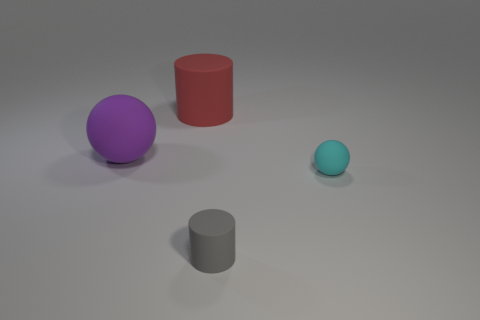Are there an equal number of tiny things that are to the left of the small cyan object and big purple things?
Make the answer very short. Yes. There is a cylinder that is to the right of the cylinder behind the gray object; is there a red rubber thing on the right side of it?
Provide a short and direct response. No. Are there fewer large red cylinders in front of the tiny gray matte object than large matte balls?
Your answer should be very brief. Yes. What number of objects are matte spheres to the right of the gray matte cylinder or purple objects on the left side of the large red cylinder?
Keep it short and to the point. 2. What is the size of the matte object that is both on the left side of the tiny cylinder and on the right side of the purple ball?
Offer a terse response. Large. Do the matte object that is to the right of the gray rubber cylinder and the big purple thing have the same shape?
Provide a short and direct response. Yes. How big is the rubber cylinder behind the rubber cylinder in front of the sphere that is left of the small matte sphere?
Offer a terse response. Large. What number of things are big gray cylinders or large rubber cylinders?
Provide a succinct answer. 1. There is a rubber thing that is in front of the purple rubber ball and on the left side of the tiny cyan thing; what is its shape?
Your answer should be compact. Cylinder. Do the gray object and the big thing to the right of the purple matte ball have the same shape?
Provide a succinct answer. Yes. 